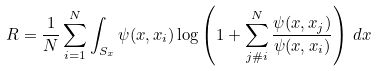Convert formula to latex. <formula><loc_0><loc_0><loc_500><loc_500>R = \frac { 1 } { N } \sum _ { i = 1 } ^ { N } \int _ { S _ { x } } \psi ( x , x _ { i } ) \log \left ( 1 + \sum _ { j \# i } ^ { N } \frac { \psi ( x , x _ { j } ) } { \psi ( x , x _ { i } ) } \right ) \, d x</formula> 